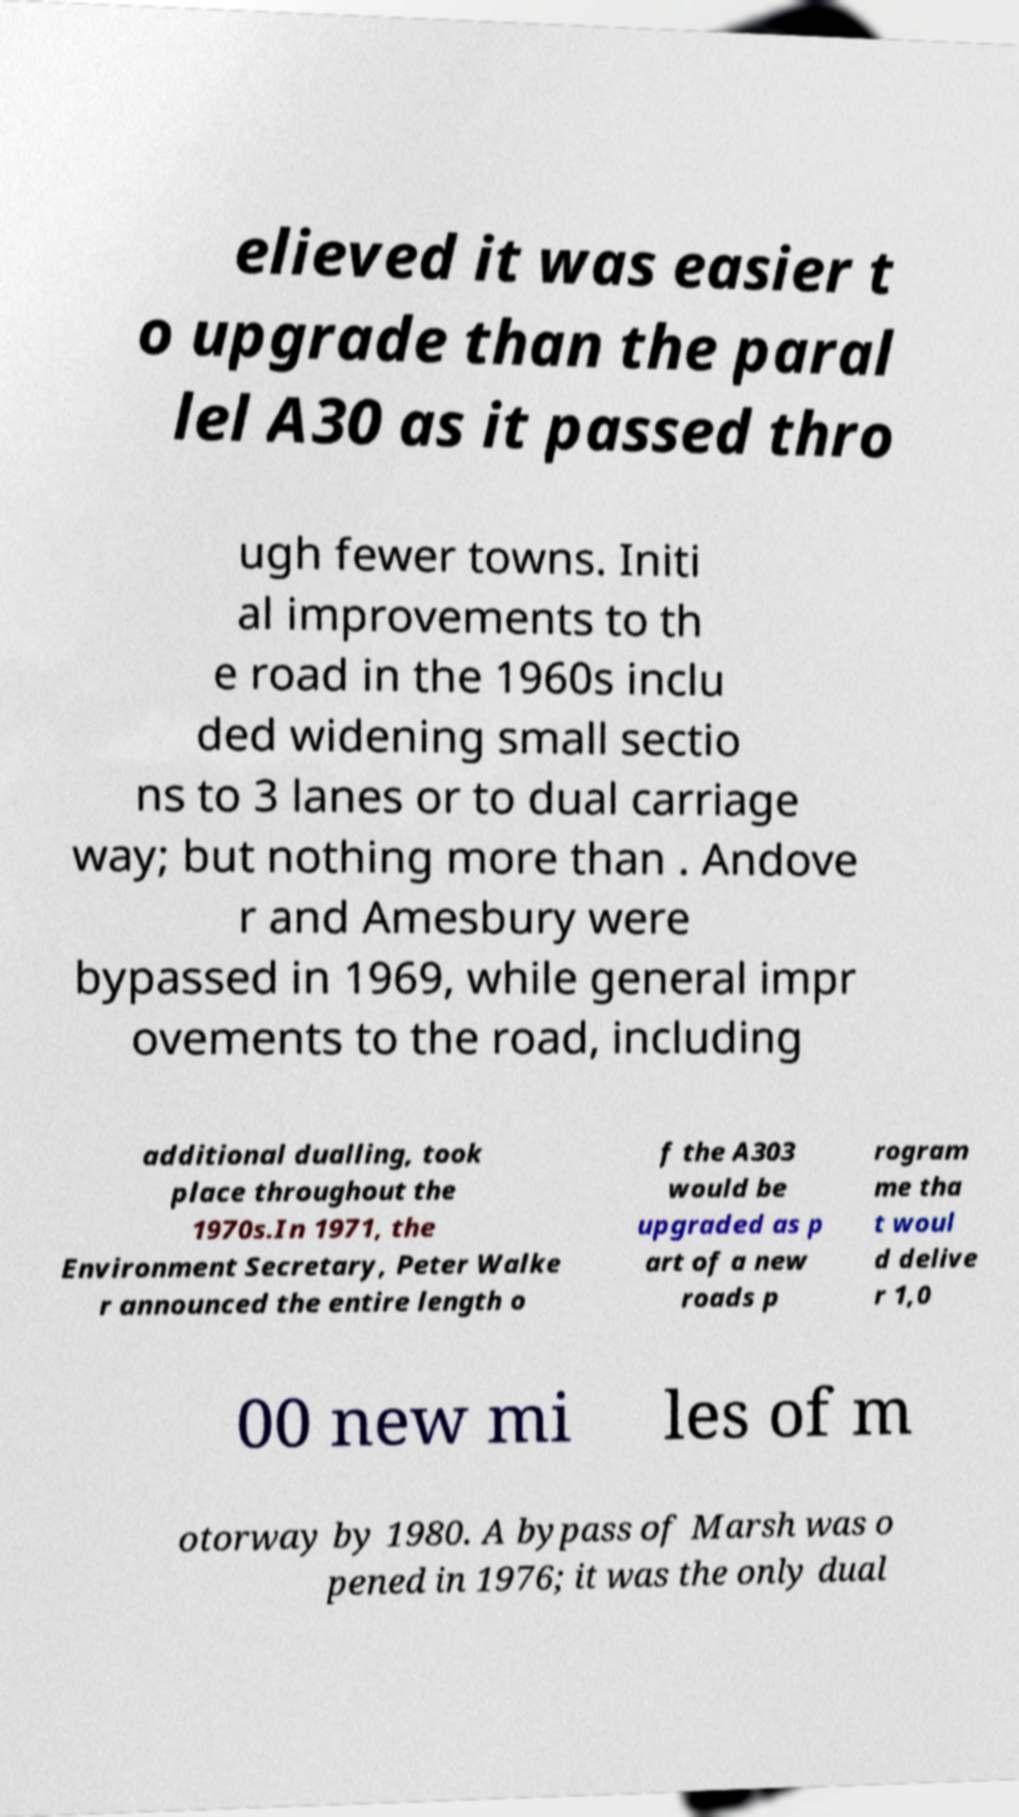Can you read and provide the text displayed in the image?This photo seems to have some interesting text. Can you extract and type it out for me? elieved it was easier t o upgrade than the paral lel A30 as it passed thro ugh fewer towns. Initi al improvements to th e road in the 1960s inclu ded widening small sectio ns to 3 lanes or to dual carriage way; but nothing more than . Andove r and Amesbury were bypassed in 1969, while general impr ovements to the road, including additional dualling, took place throughout the 1970s.In 1971, the Environment Secretary, Peter Walke r announced the entire length o f the A303 would be upgraded as p art of a new roads p rogram me tha t woul d delive r 1,0 00 new mi les of m otorway by 1980. A bypass of Marsh was o pened in 1976; it was the only dual 